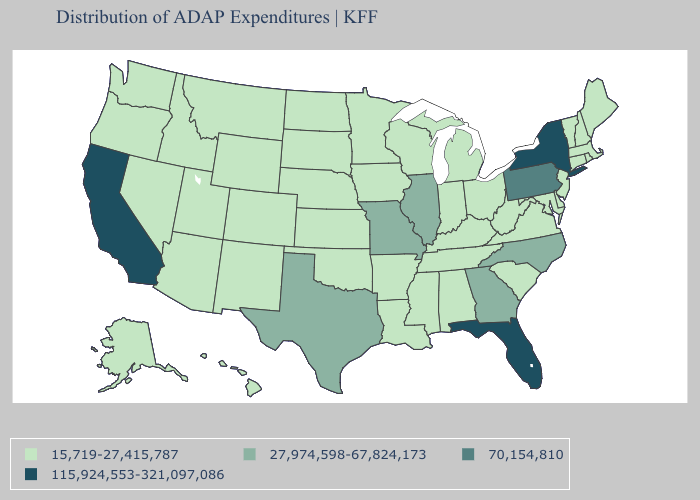What is the value of Missouri?
Short answer required. 27,974,598-67,824,173. Does Florida have the highest value in the South?
Concise answer only. Yes. What is the value of Mississippi?
Answer briefly. 15,719-27,415,787. Name the states that have a value in the range 27,974,598-67,824,173?
Short answer required. Georgia, Illinois, Missouri, North Carolina, Texas. Does Louisiana have the lowest value in the South?
Be succinct. Yes. Does Utah have the highest value in the USA?
Give a very brief answer. No. What is the value of Nevada?
Quick response, please. 15,719-27,415,787. What is the highest value in the USA?
Short answer required. 115,924,553-321,097,086. Does the first symbol in the legend represent the smallest category?
Be succinct. Yes. Does South Carolina have the lowest value in the USA?
Write a very short answer. Yes. Which states have the lowest value in the MidWest?
Write a very short answer. Indiana, Iowa, Kansas, Michigan, Minnesota, Nebraska, North Dakota, Ohio, South Dakota, Wisconsin. What is the value of Kansas?
Concise answer only. 15,719-27,415,787. What is the value of Pennsylvania?
Keep it brief. 70,154,810. Name the states that have a value in the range 70,154,810?
Concise answer only. Pennsylvania. Does the map have missing data?
Be succinct. No. 